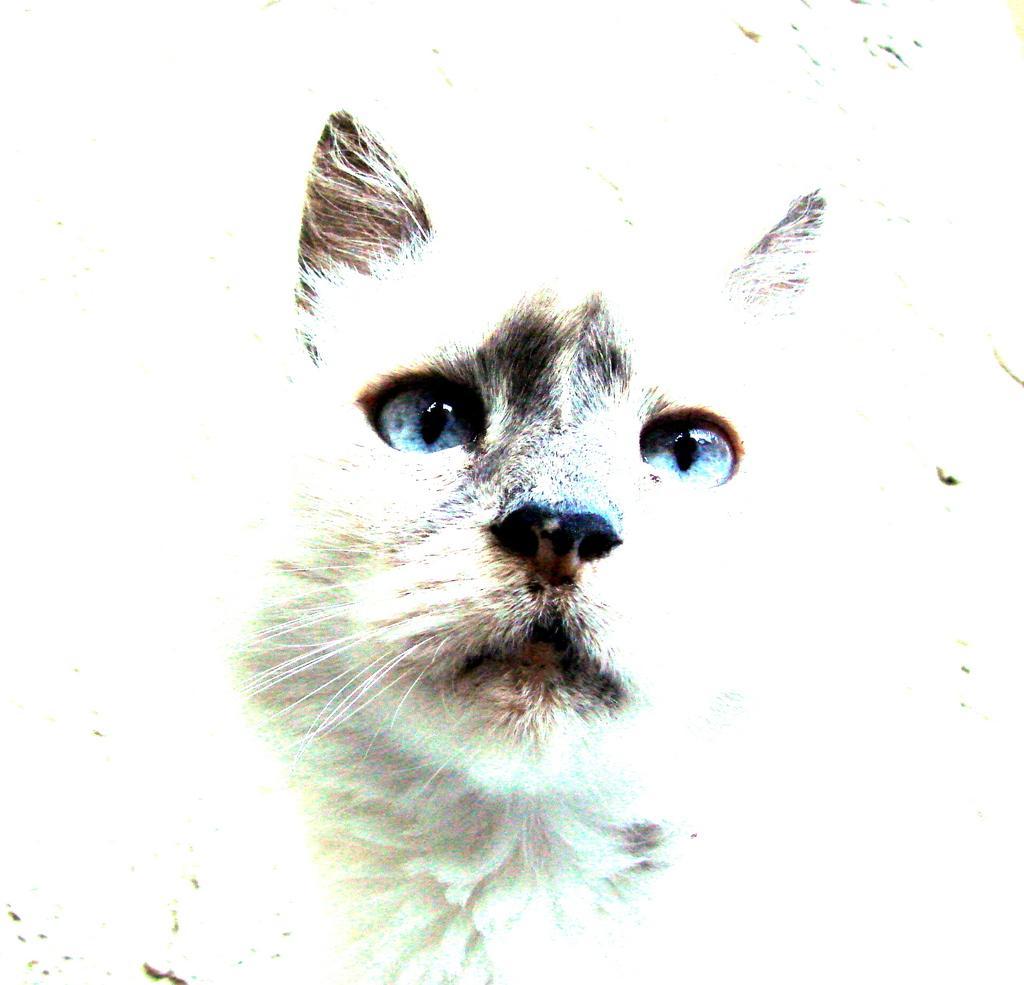How would you summarize this image in a sentence or two? In this image we can see an animal. The background of the image is bright. 